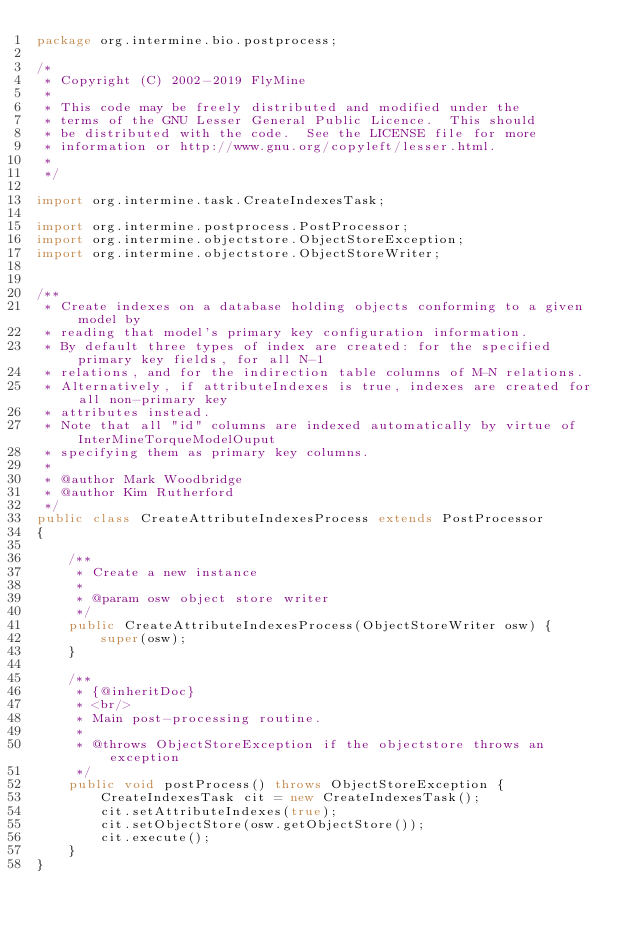<code> <loc_0><loc_0><loc_500><loc_500><_Java_>package org.intermine.bio.postprocess;

/*
 * Copyright (C) 2002-2019 FlyMine
 *
 * This code may be freely distributed and modified under the
 * terms of the GNU Lesser General Public Licence.  This should
 * be distributed with the code.  See the LICENSE file for more
 * information or http://www.gnu.org/copyleft/lesser.html.
 *
 */

import org.intermine.task.CreateIndexesTask;

import org.intermine.postprocess.PostProcessor;
import org.intermine.objectstore.ObjectStoreException;
import org.intermine.objectstore.ObjectStoreWriter;


/**
 * Create indexes on a database holding objects conforming to a given model by
 * reading that model's primary key configuration information.
 * By default three types of index are created: for the specified primary key fields, for all N-1
 * relations, and for the indirection table columns of M-N relations.
 * Alternatively, if attributeIndexes is true, indexes are created for all non-primary key
 * attributes instead.
 * Note that all "id" columns are indexed automatically by virtue of InterMineTorqueModelOuput
 * specifying them as primary key columns.
 *
 * @author Mark Woodbridge
 * @author Kim Rutherford
 */
public class CreateAttributeIndexesProcess extends PostProcessor
{

    /**
     * Create a new instance
     *
     * @param osw object store writer
     */
    public CreateAttributeIndexesProcess(ObjectStoreWriter osw) {
        super(osw);
    }

    /**
     * {@inheritDoc}
     * <br/>
     * Main post-processing routine.
     *
     * @throws ObjectStoreException if the objectstore throws an exception
     */
    public void postProcess() throws ObjectStoreException {
        CreateIndexesTask cit = new CreateIndexesTask();
        cit.setAttributeIndexes(true);
        cit.setObjectStore(osw.getObjectStore());
        cit.execute();
    }
}
</code> 